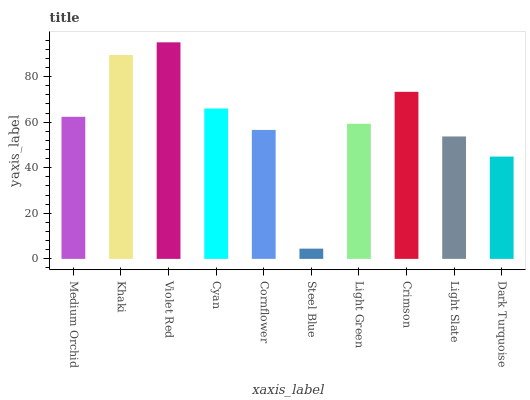Is Steel Blue the minimum?
Answer yes or no. Yes. Is Violet Red the maximum?
Answer yes or no. Yes. Is Khaki the minimum?
Answer yes or no. No. Is Khaki the maximum?
Answer yes or no. No. Is Khaki greater than Medium Orchid?
Answer yes or no. Yes. Is Medium Orchid less than Khaki?
Answer yes or no. Yes. Is Medium Orchid greater than Khaki?
Answer yes or no. No. Is Khaki less than Medium Orchid?
Answer yes or no. No. Is Medium Orchid the high median?
Answer yes or no. Yes. Is Light Green the low median?
Answer yes or no. Yes. Is Violet Red the high median?
Answer yes or no. No. Is Steel Blue the low median?
Answer yes or no. No. 